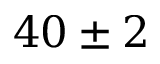Convert formula to latex. <formula><loc_0><loc_0><loc_500><loc_500>4 0 \pm 2</formula> 